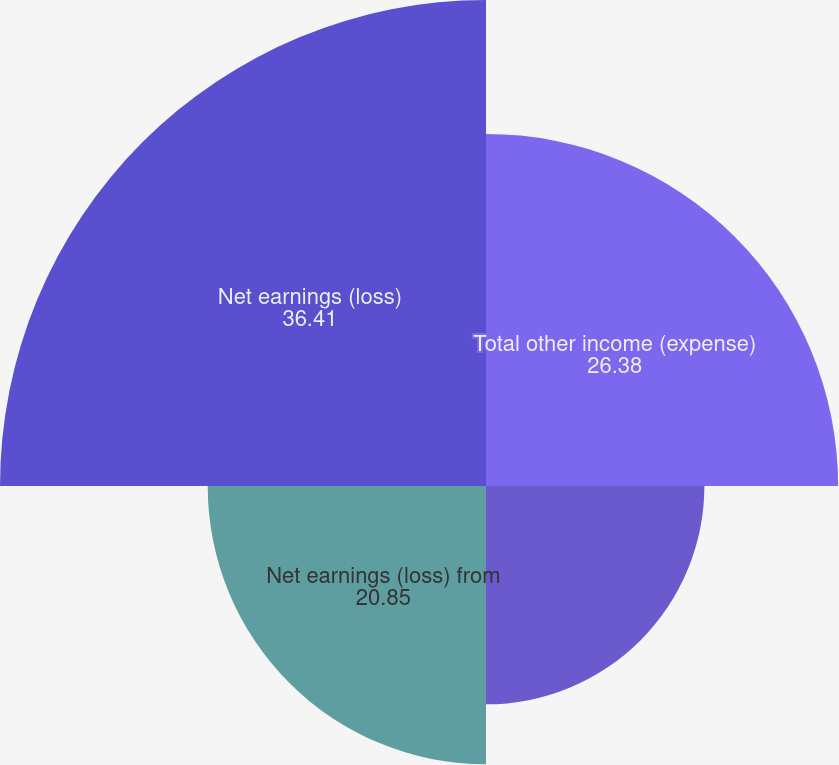Convert chart to OTSL. <chart><loc_0><loc_0><loc_500><loc_500><pie_chart><fcel>Total other income (expense)<fcel>Earnings (loss) from<fcel>Net earnings (loss) from<fcel>Net earnings (loss)<nl><fcel>26.38%<fcel>16.36%<fcel>20.85%<fcel>36.41%<nl></chart> 